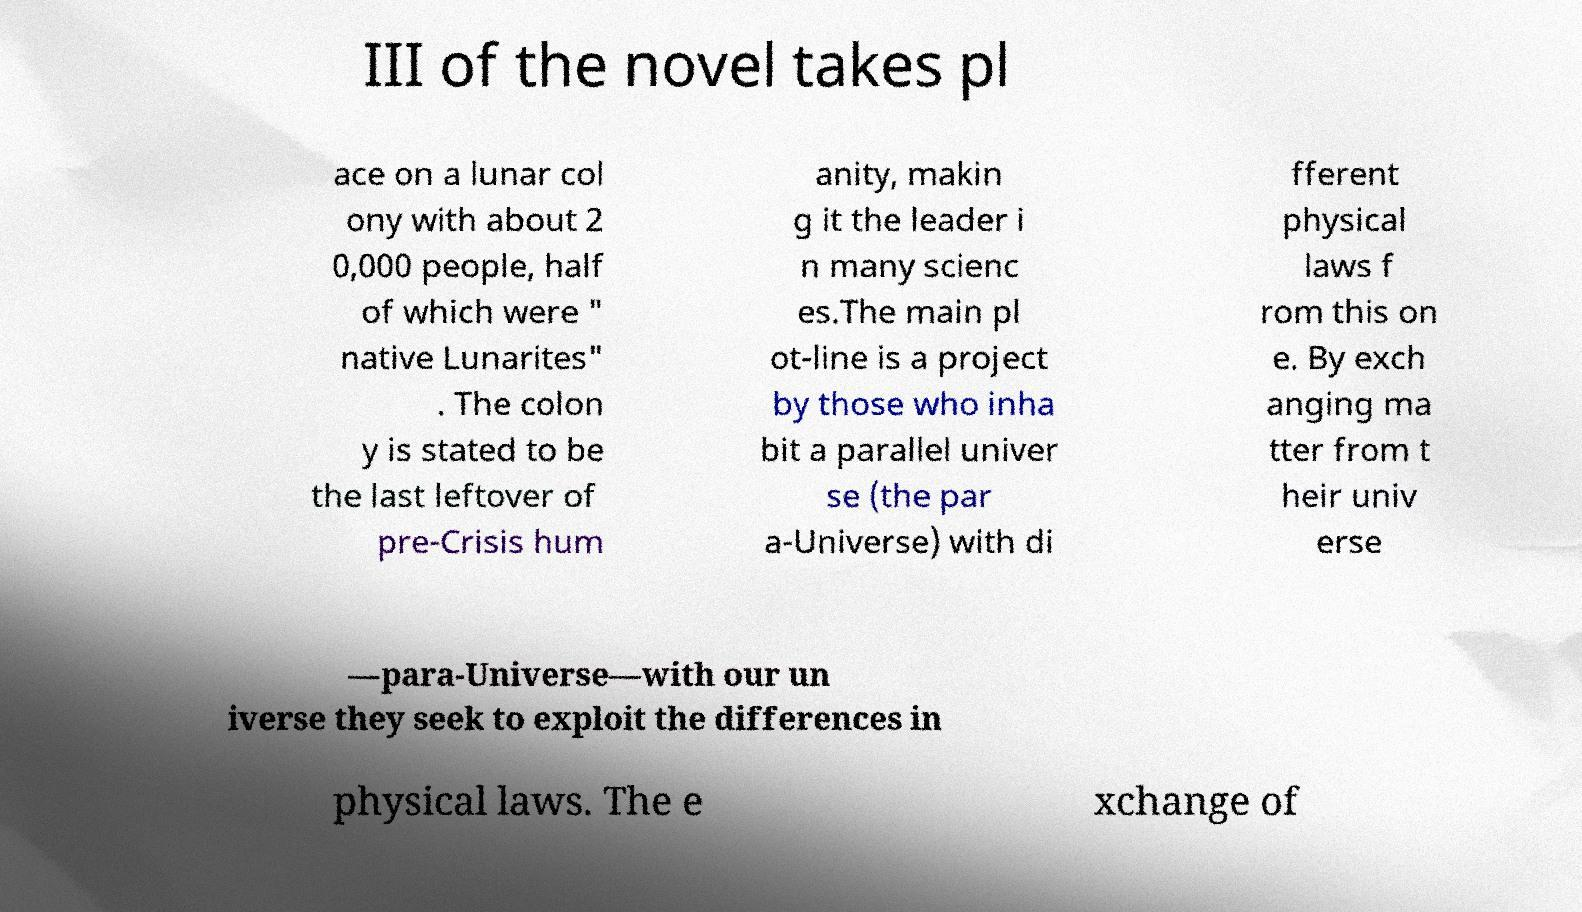Please identify and transcribe the text found in this image. III of the novel takes pl ace on a lunar col ony with about 2 0,000 people, half of which were " native Lunarites" . The colon y is stated to be the last leftover of pre-Crisis hum anity, makin g it the leader i n many scienc es.The main pl ot-line is a project by those who inha bit a parallel univer se (the par a-Universe) with di fferent physical laws f rom this on e. By exch anging ma tter from t heir univ erse —para-Universe—with our un iverse they seek to exploit the differences in physical laws. The e xchange of 